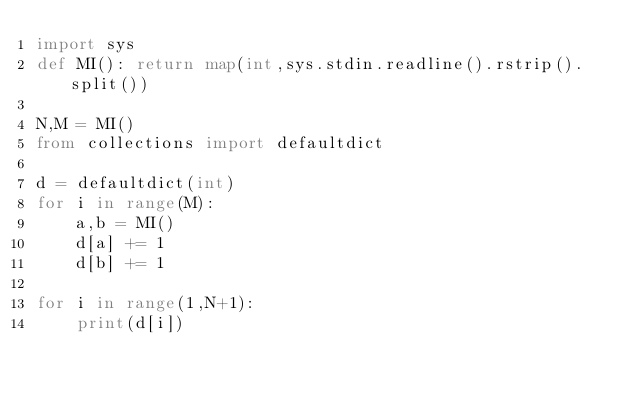Convert code to text. <code><loc_0><loc_0><loc_500><loc_500><_Python_>import sys
def MI(): return map(int,sys.stdin.readline().rstrip().split())

N,M = MI()
from collections import defaultdict

d = defaultdict(int)
for i in range(M):
    a,b = MI()
    d[a] += 1
    d[b] += 1

for i in range(1,N+1):
    print(d[i])</code> 